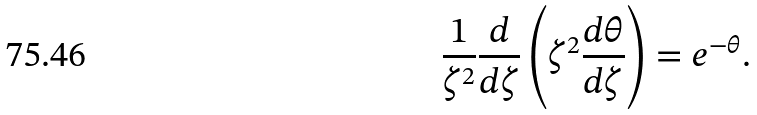Convert formula to latex. <formula><loc_0><loc_0><loc_500><loc_500>\frac { 1 } { \zeta ^ { 2 } } \frac { d } { d \zeta } \left ( \zeta ^ { 2 } \frac { d \theta } { d \zeta } \right ) = e ^ { - \theta } .</formula> 